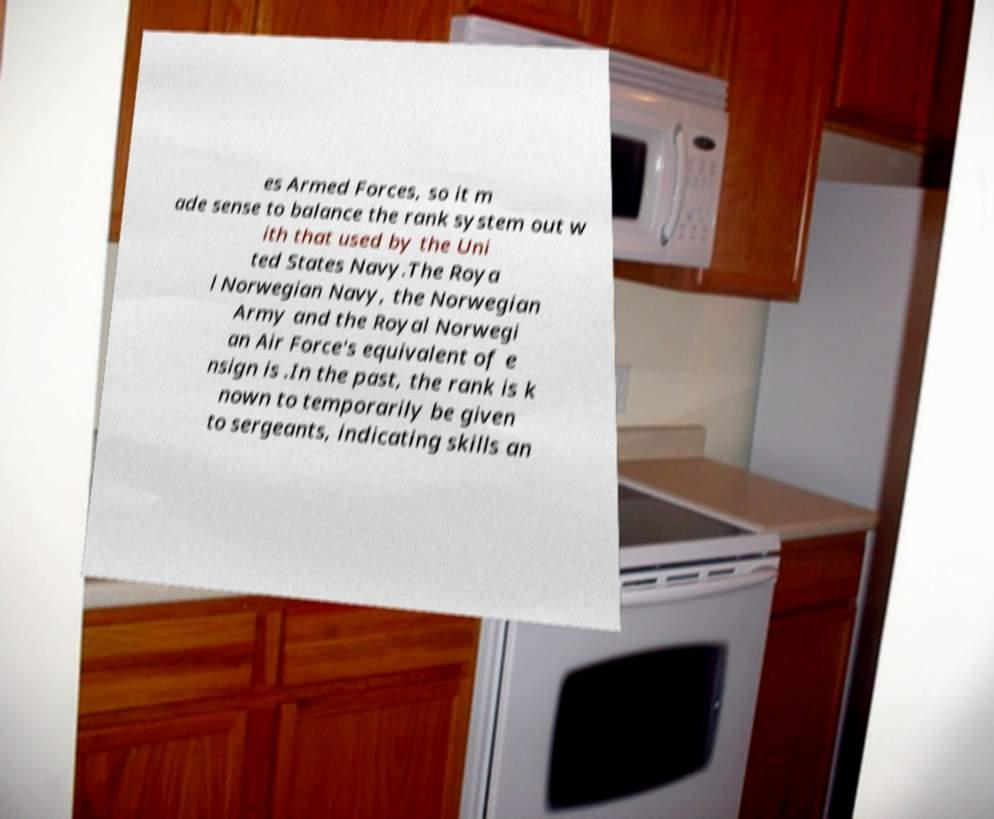For documentation purposes, I need the text within this image transcribed. Could you provide that? es Armed Forces, so it m ade sense to balance the rank system out w ith that used by the Uni ted States Navy.The Roya l Norwegian Navy, the Norwegian Army and the Royal Norwegi an Air Force's equivalent of e nsign is .In the past, the rank is k nown to temporarily be given to sergeants, indicating skills an 